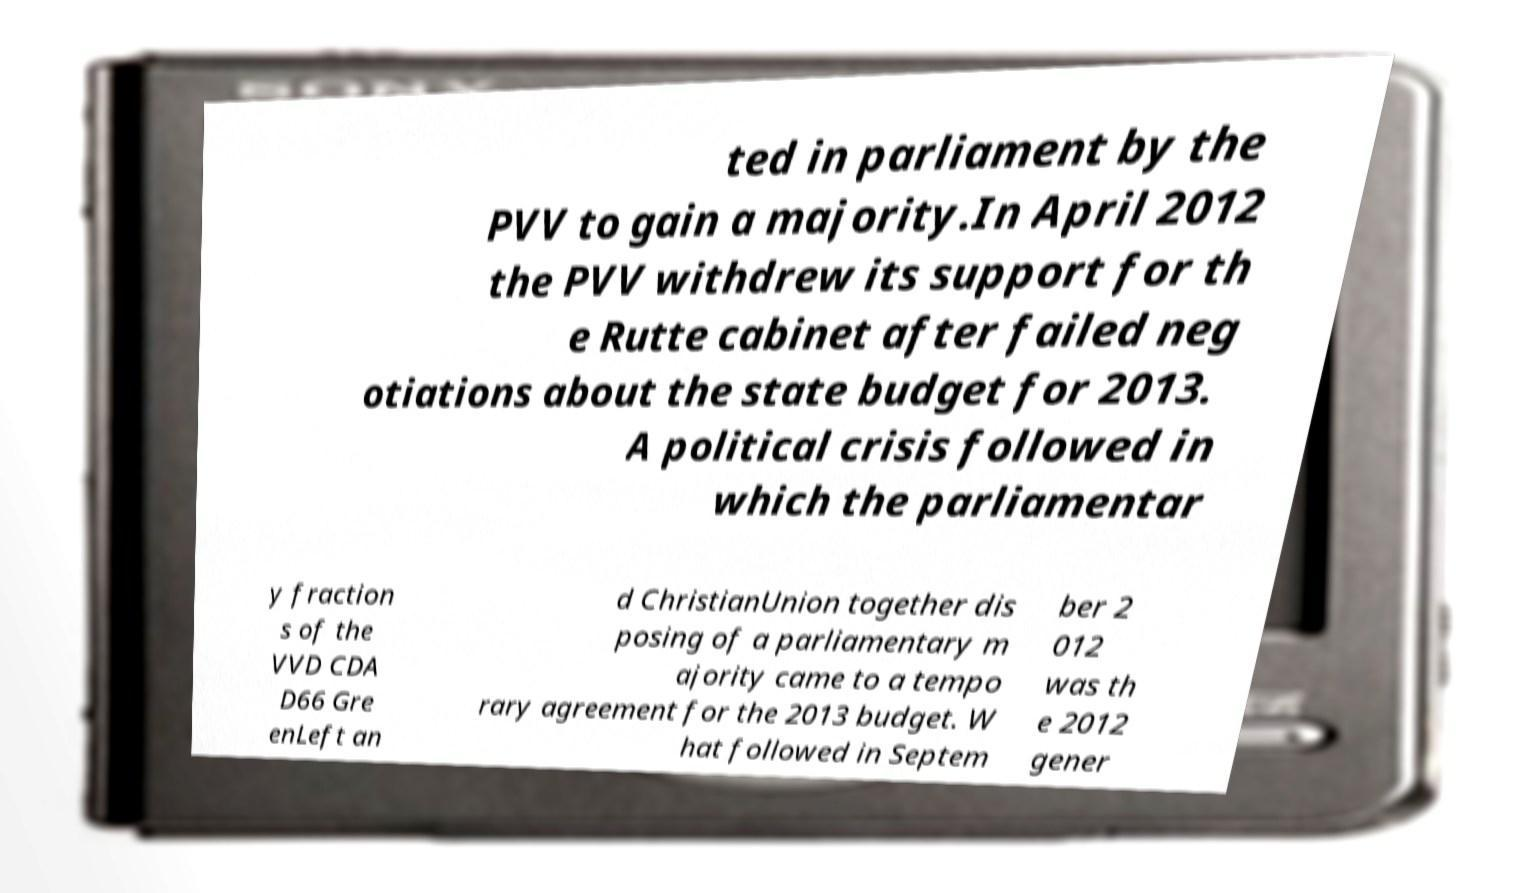Could you extract and type out the text from this image? ted in parliament by the PVV to gain a majority.In April 2012 the PVV withdrew its support for th e Rutte cabinet after failed neg otiations about the state budget for 2013. A political crisis followed in which the parliamentar y fraction s of the VVD CDA D66 Gre enLeft an d ChristianUnion together dis posing of a parliamentary m ajority came to a tempo rary agreement for the 2013 budget. W hat followed in Septem ber 2 012 was th e 2012 gener 